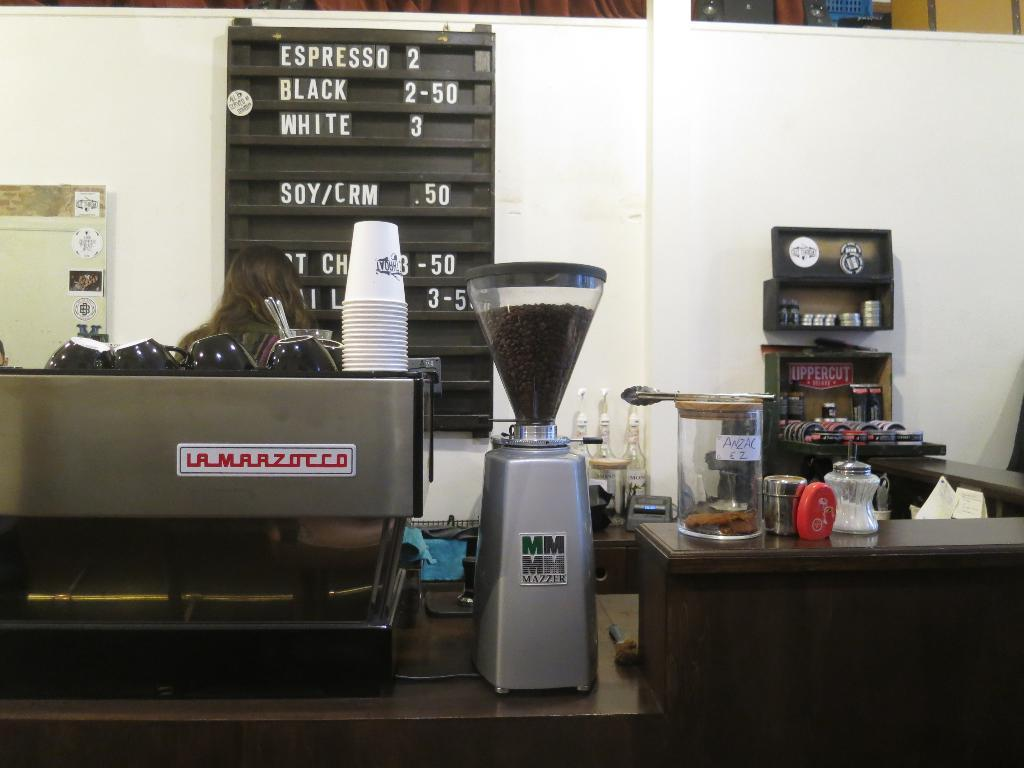<image>
Provide a brief description of the given image. A menu in a coffee shop offering different types of coffee. 